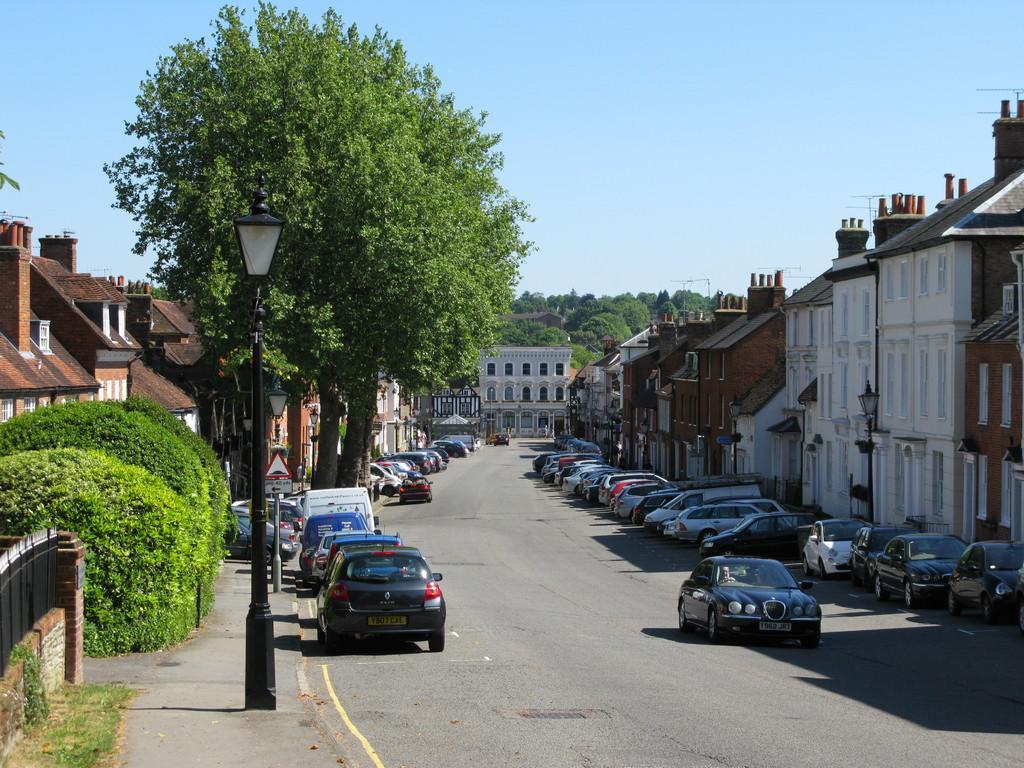Could you give a brief overview of what you see in this image? In this picture we can see vehicles on the road, light poles, sign board, fence, trees, buildings with windows and some objects and in the background we can see the sky. 